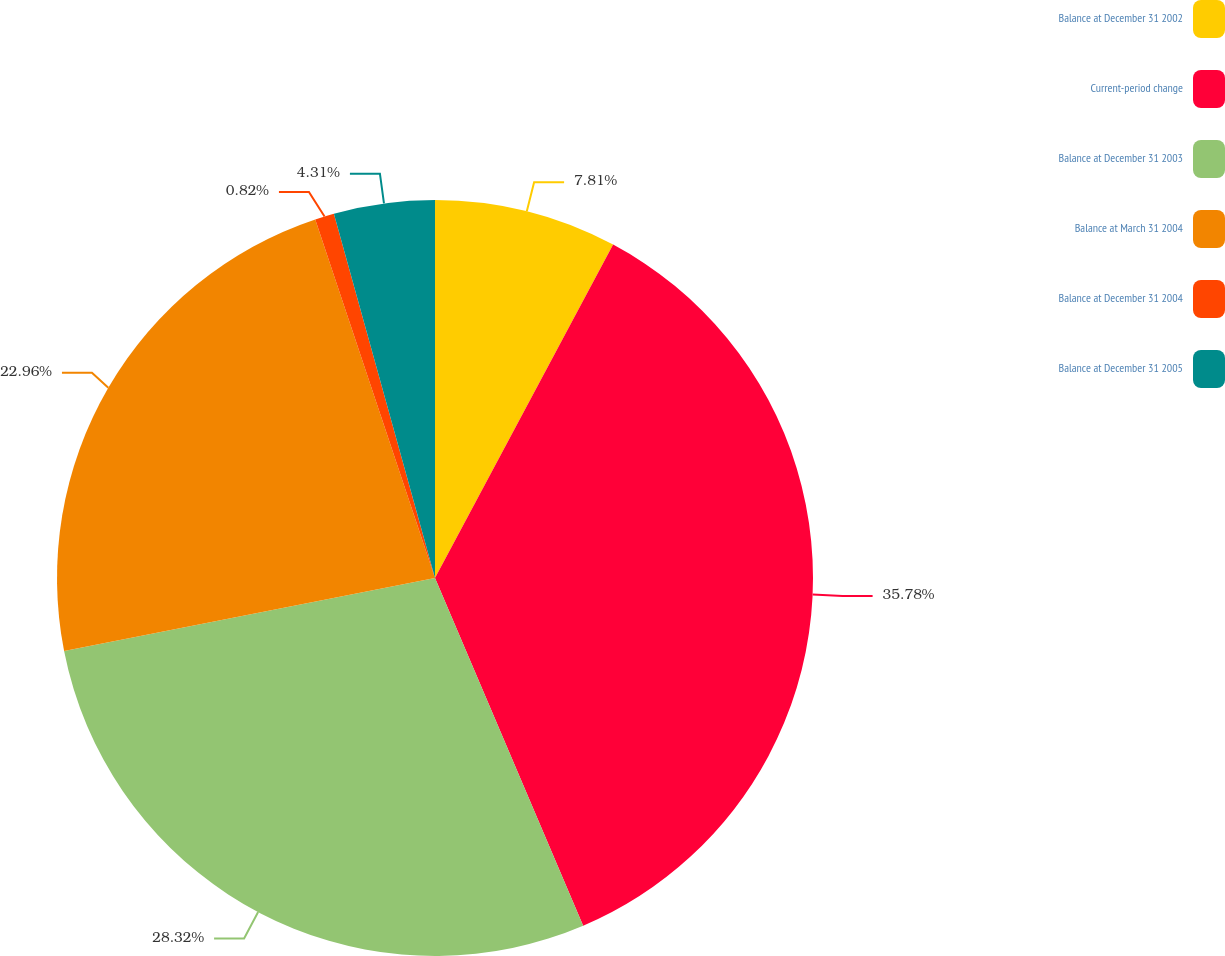Convert chart to OTSL. <chart><loc_0><loc_0><loc_500><loc_500><pie_chart><fcel>Balance at December 31 2002<fcel>Current-period change<fcel>Balance at December 31 2003<fcel>Balance at March 31 2004<fcel>Balance at December 31 2004<fcel>Balance at December 31 2005<nl><fcel>7.81%<fcel>35.78%<fcel>28.32%<fcel>22.96%<fcel>0.82%<fcel>4.31%<nl></chart> 